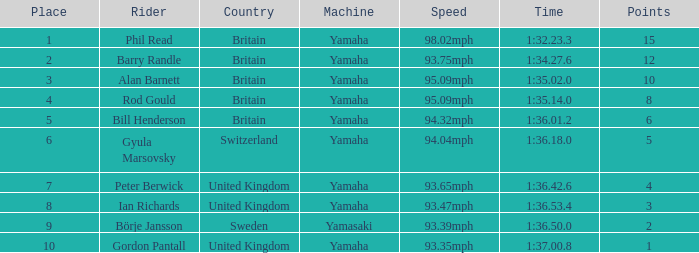What was the time for the man who scored 1 point? 1:37.00.8. 